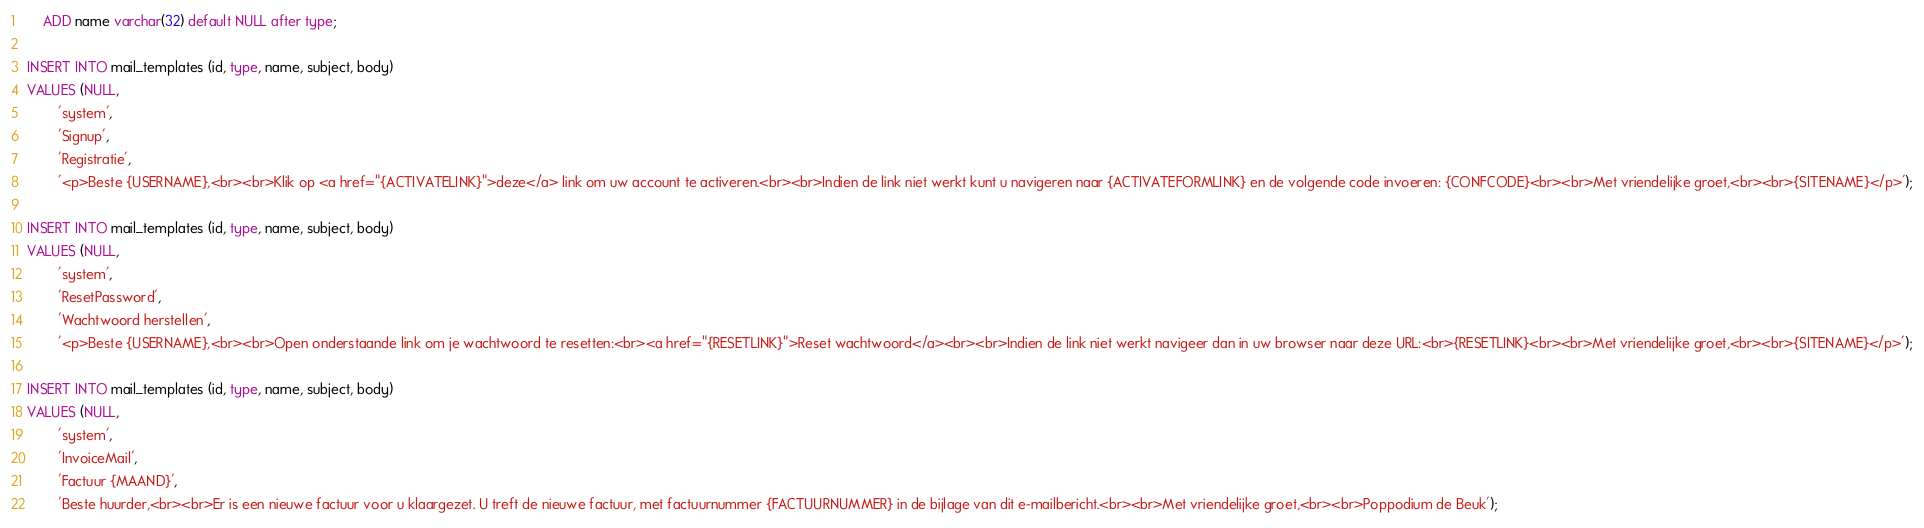<code> <loc_0><loc_0><loc_500><loc_500><_SQL_>    ADD name varchar(32) default NULL after type;

INSERT INTO mail_templates (id, type, name, subject, body)
VALUES (NULL,
        'system',
        'Signup',
        'Registratie',
        '<p>Beste {USERNAME},<br><br>Klik op <a href="{ACTIVATELINK}">deze</a> link om uw account te activeren.<br><br>Indien de link niet werkt kunt u navigeren naar {ACTIVATEFORMLINK} en de volgende code invoeren: {CONFCODE}<br><br>Met vriendelijke groet,<br><br>{SITENAME}</p>');

INSERT INTO mail_templates (id, type, name, subject, body)
VALUES (NULL,
        'system',
        'ResetPassword',
        'Wachtwoord herstellen',
        '<p>Beste {USERNAME},<br><br>Open onderstaande link om je wachtwoord te resetten:<br><a href="{RESETLINK}">Reset wachtwoord</a><br><br>Indien de link niet werkt navigeer dan in uw browser naar deze URL:<br>{RESETLINK}<br><br>Met vriendelijke groet,<br><br>{SITENAME}</p>');

INSERT INTO mail_templates (id, type, name, subject, body)
VALUES (NULL,
        'system',
        'InvoiceMail',
        'Factuur {MAAND}',
        'Beste huurder,<br><br>Er is een nieuwe factuur voor u klaargezet. U treft de nieuwe factuur, met factuurnummer {FACTUURNUMMER} in de bijlage van dit e-mailbericht.<br><br>Met vriendelijke groet,<br><br>Poppodium de Beuk');
</code> 